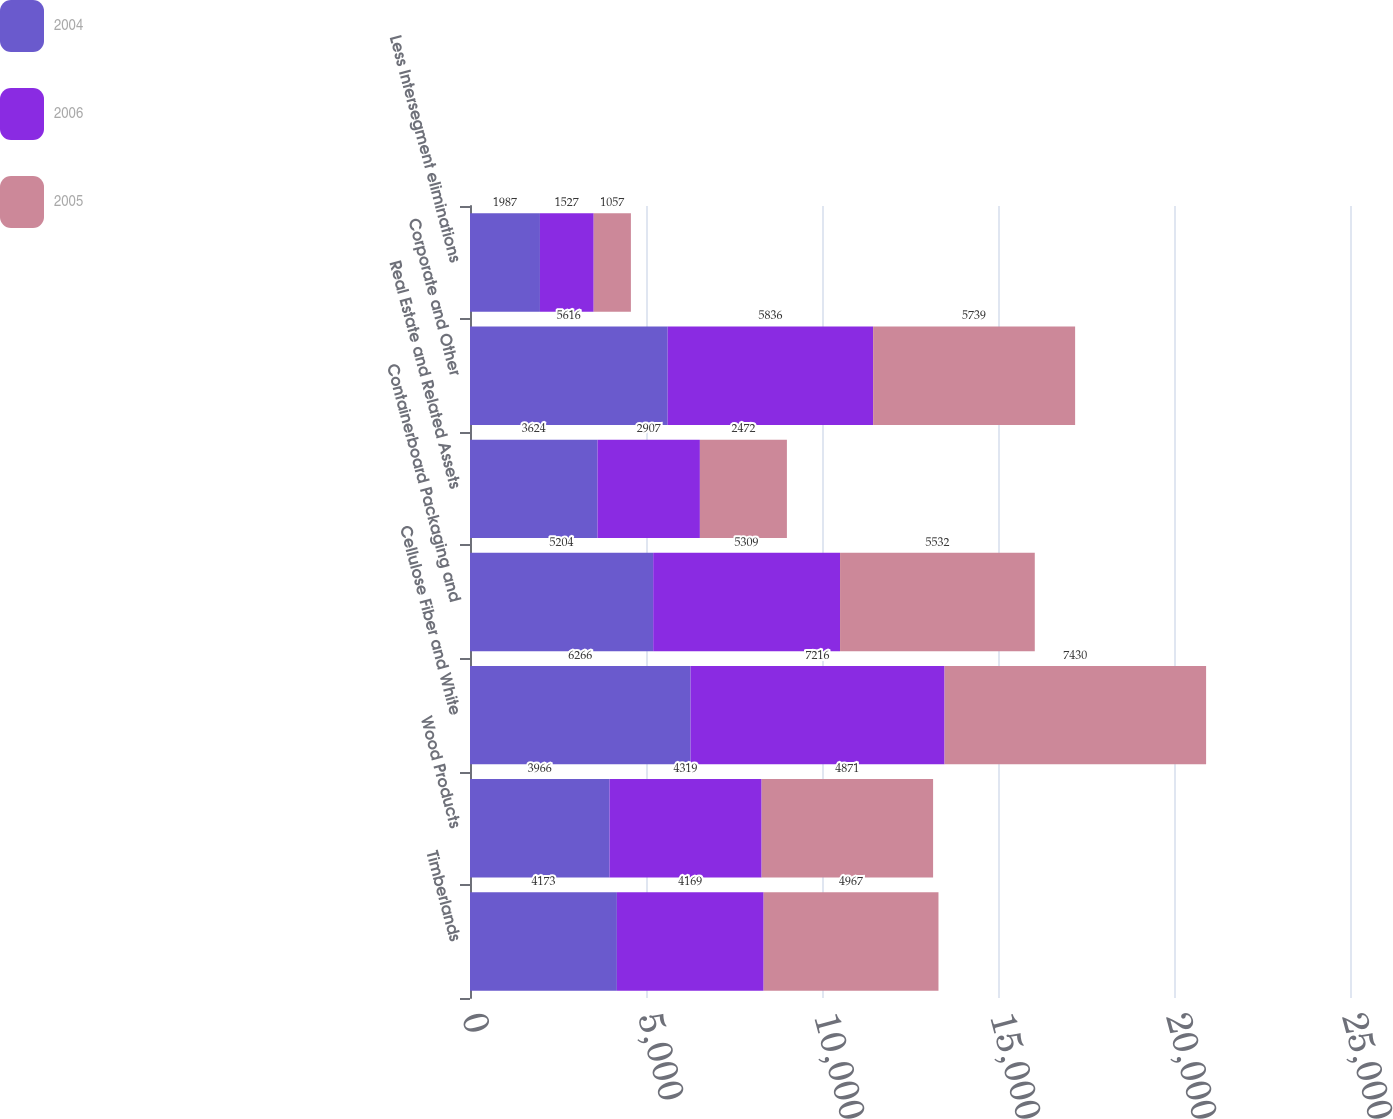Convert chart to OTSL. <chart><loc_0><loc_0><loc_500><loc_500><stacked_bar_chart><ecel><fcel>Timberlands<fcel>Wood Products<fcel>Cellulose Fiber and White<fcel>Containerboard Packaging and<fcel>Real Estate and Related Assets<fcel>Corporate and Other<fcel>Less Intersegment eliminations<nl><fcel>2004<fcel>4173<fcel>3966<fcel>6266<fcel>5204<fcel>3624<fcel>5616<fcel>1987<nl><fcel>2006<fcel>4169<fcel>4319<fcel>7216<fcel>5309<fcel>2907<fcel>5836<fcel>1527<nl><fcel>2005<fcel>4967<fcel>4871<fcel>7430<fcel>5532<fcel>2472<fcel>5739<fcel>1057<nl></chart> 